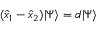Convert formula to latex. <formula><loc_0><loc_0><loc_500><loc_500>( \hat { x } _ { 1 } - \hat { x } _ { 2 } ) | \Psi \rangle = d | \Psi \rangle</formula> 